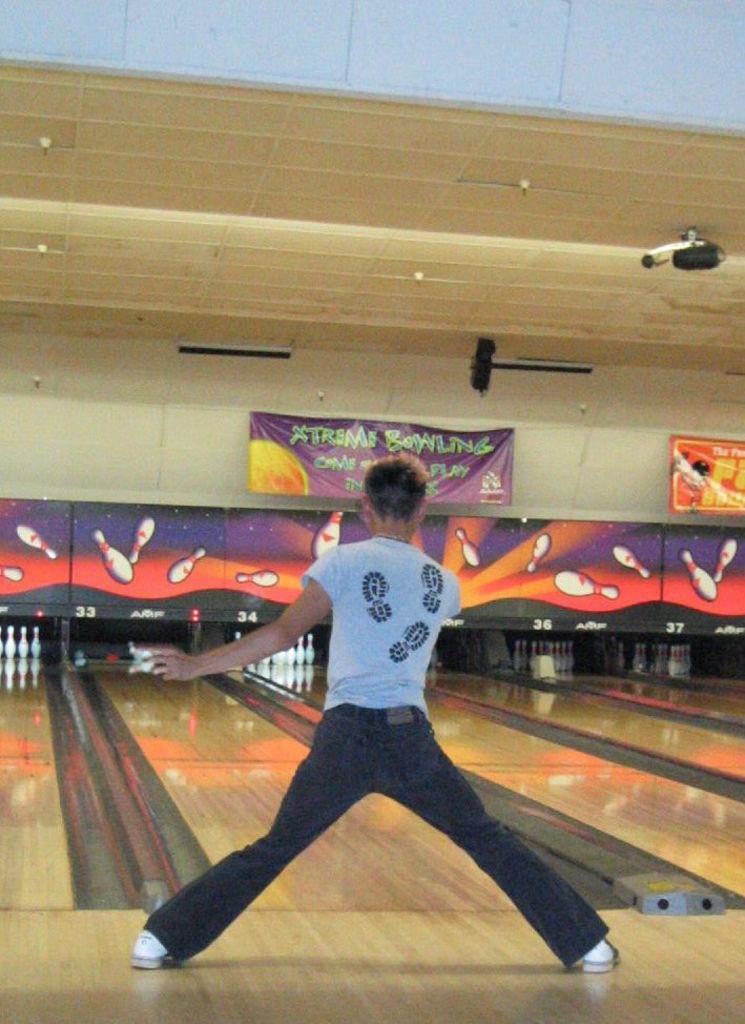Can you describe this image briefly? In this image I can see the person with the dress. In the background I can see the bowling-pins and the banners. I can see the lights at the top. 